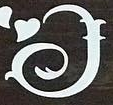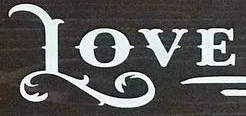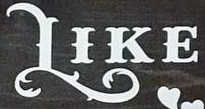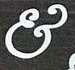What words are shown in these images in order, separated by a semicolon? I; LOVE; LIKE; & 